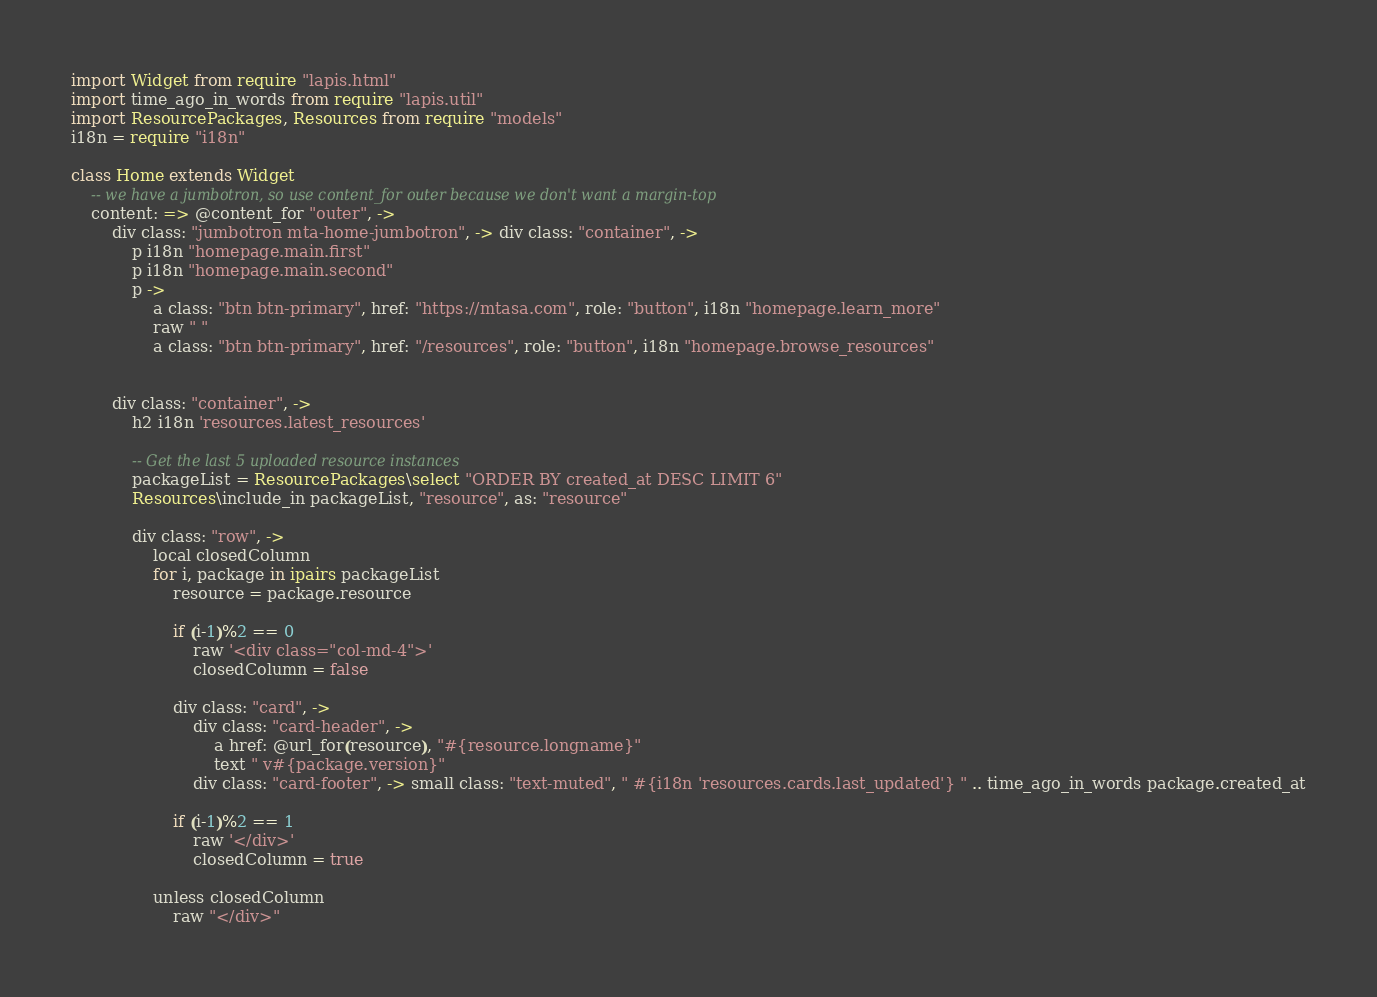Convert code to text. <code><loc_0><loc_0><loc_500><loc_500><_MoonScript_>import Widget from require "lapis.html"
import time_ago_in_words from require "lapis.util"
import ResourcePackages, Resources from require "models"
i18n = require "i18n"

class Home extends Widget
	-- we have a jumbotron, so use content_for outer because we don't want a margin-top
	content: => @content_for "outer", ->
		div class: "jumbotron mta-home-jumbotron", -> div class: "container", ->
			p i18n "homepage.main.first"
			p i18n "homepage.main.second"
			p ->
				a class: "btn btn-primary", href: "https://mtasa.com", role: "button", i18n "homepage.learn_more"
				raw " "
				a class: "btn btn-primary", href: "/resources", role: "button", i18n "homepage.browse_resources"

		
		div class: "container", ->
			h2 i18n 'resources.latest_resources'

			-- Get the last 5 uploaded resource instances
			packageList = ResourcePackages\select "ORDER BY created_at DESC LIMIT 6"
			Resources\include_in packageList, "resource", as: "resource"

			div class: "row", ->
				local closedColumn
				for i, package in ipairs packageList
					resource = package.resource

					if (i-1)%2 == 0
						raw '<div class="col-md-4">'
						closedColumn = false

					div class: "card", ->
						div class: "card-header", ->
							a href: @url_for(resource), "#{resource.longname}"
							text " v#{package.version}"
						div class: "card-footer", -> small class: "text-muted", " #{i18n 'resources.cards.last_updated'} " .. time_ago_in_words package.created_at
					
					if (i-1)%2 == 1
						raw '</div>'
						closedColumn = true

				unless closedColumn
					raw "</div>"
</code> 